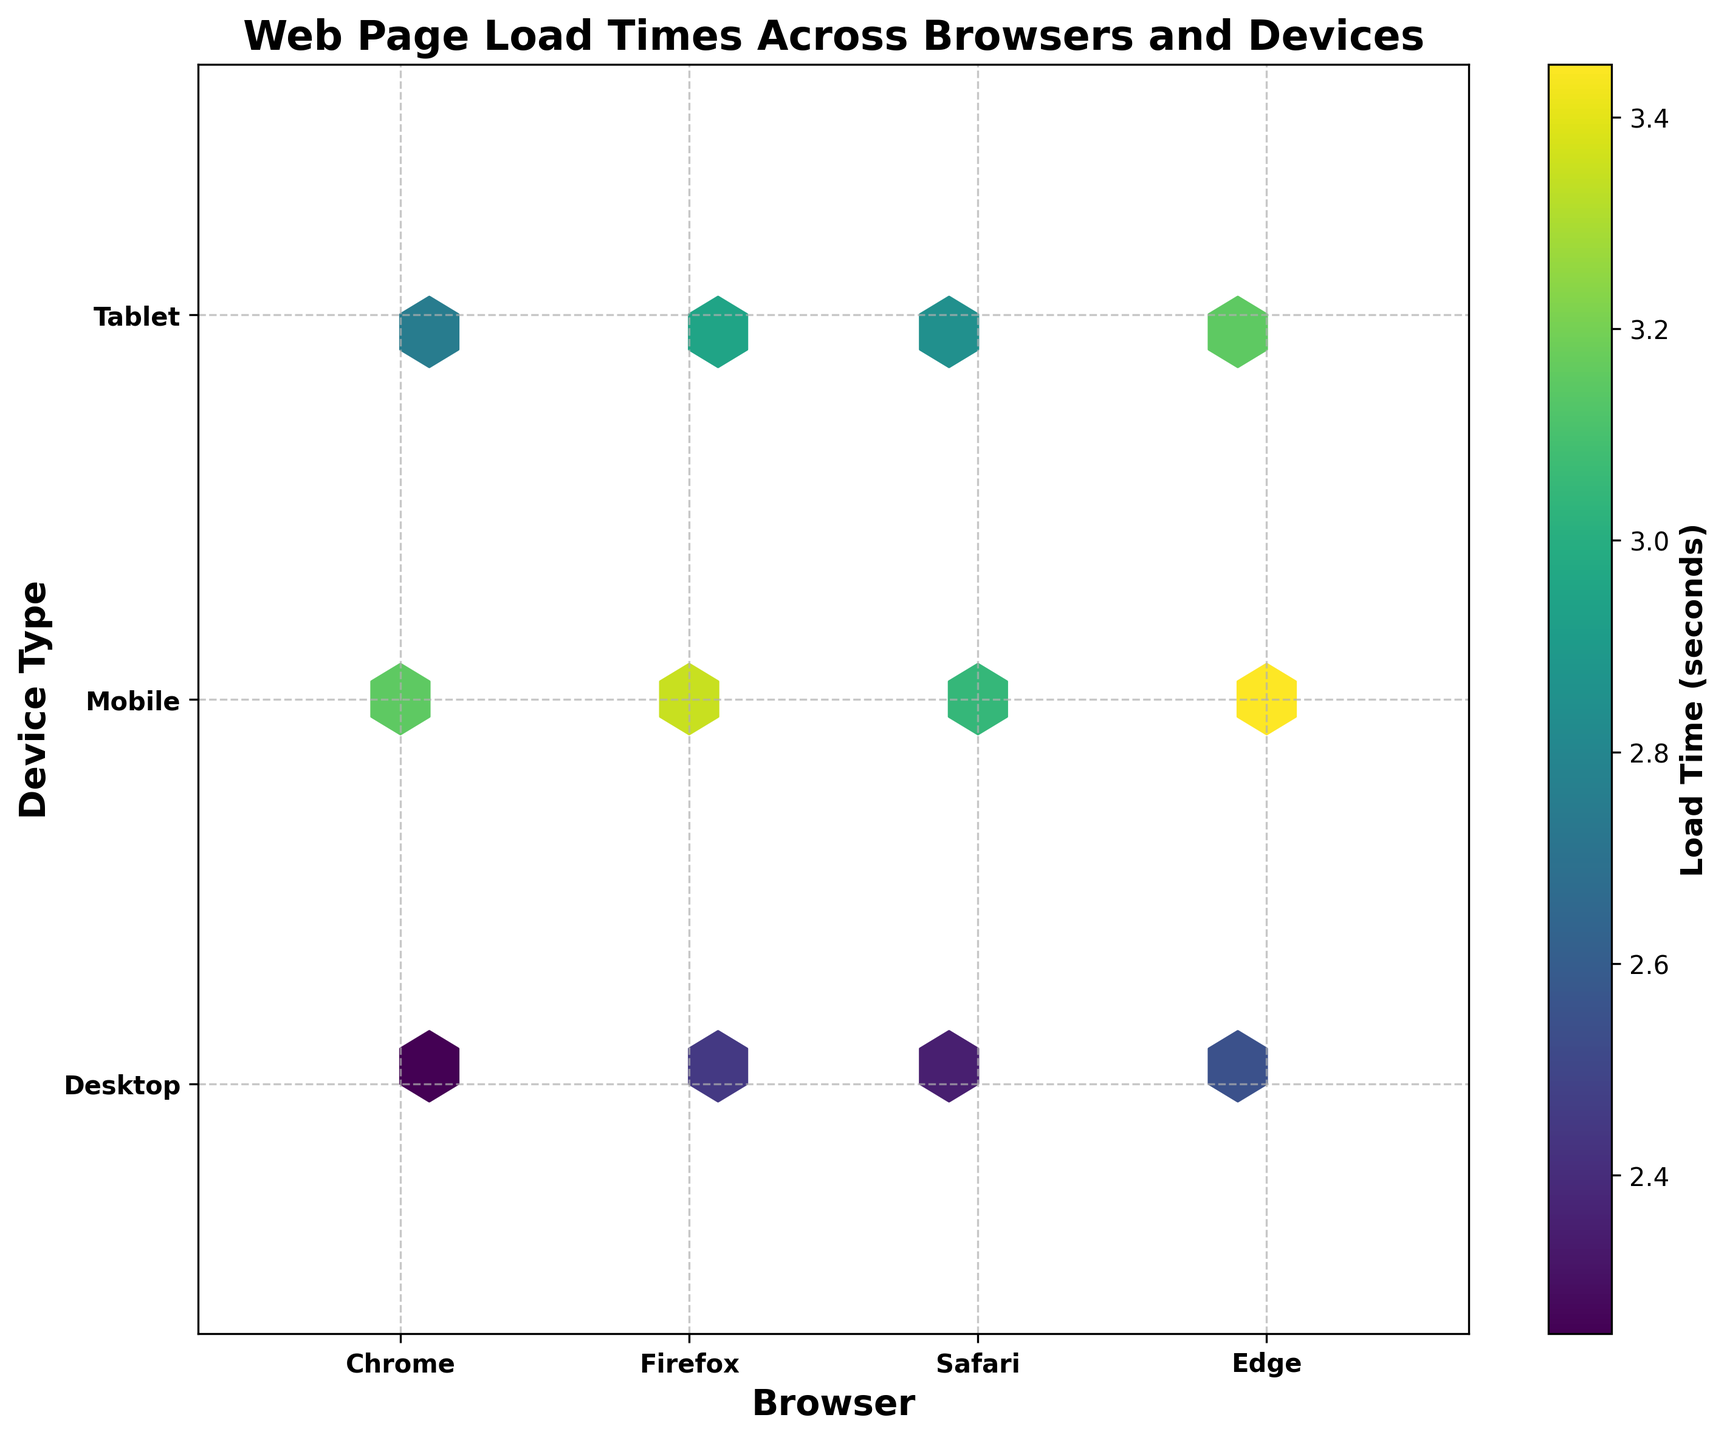Which browser and device combination shows the quickest load time? The color bar shows load times, with lighter colors indicating quicker times. The lightest hexbin is located at the intersection of 'Chrome' and 'Desktop'.
Answer: Chrome on Desktop What is the title of the figure? The title is displayed at the top of the figure.
Answer: Web Page Load Times Across Browsers and Devices What do the x-axis and y-axis represent? The x-axis represents different browsers, while the y-axis represents different device types.
Answer: Browsers and Device Types Which device type generally has the highest load times? The color bar indicates load times, with darker colors showing higher values. Most of the darkest hexbin points are on the 'Mobile' row.
Answer: Mobile What is the average load time for Safari on Tablets? Identify the color intensity at the 'Safari' browser and 'Tablet' device intersection, convert it to a value using the color bar. The color shows an average around 2.85 seconds.
Answer: Approximately 2.85 seconds Which browser shows the most consistent load time across all devices? Consistency can be inferred where the color variation across devices is minimal. Chrome's row shows the smallest change in color.
Answer: Chrome Between Firefox and Edge, which browser has lower load times on Mobile devices? Compare the color patches for 'Firefox' and 'Edge' on the 'Mobile' row. Firefox’s hexbin is lighter than Edge's.
Answer: Firefox Which browser shows the least difference in load times between Desktop and Mobile devices? This involves comparing the color differences between the 'Desktop' and 'Mobile' cells for each browser. Firefox shows the least color difference.
Answer: Firefox Do Tablets have generally lower load times than Mobiles across all browsers? By comparing the average color tone across the tablet row and mobile row, tablet rows are lighter.
Answer: Yes, Tablets are generally quicker For which device type does Edge exhibit the worst load time performance? Find the darkest hexbin points in the 'Edge' column across device rows. The darkest is found at the 'Mobile' row.
Answer: Mobile 